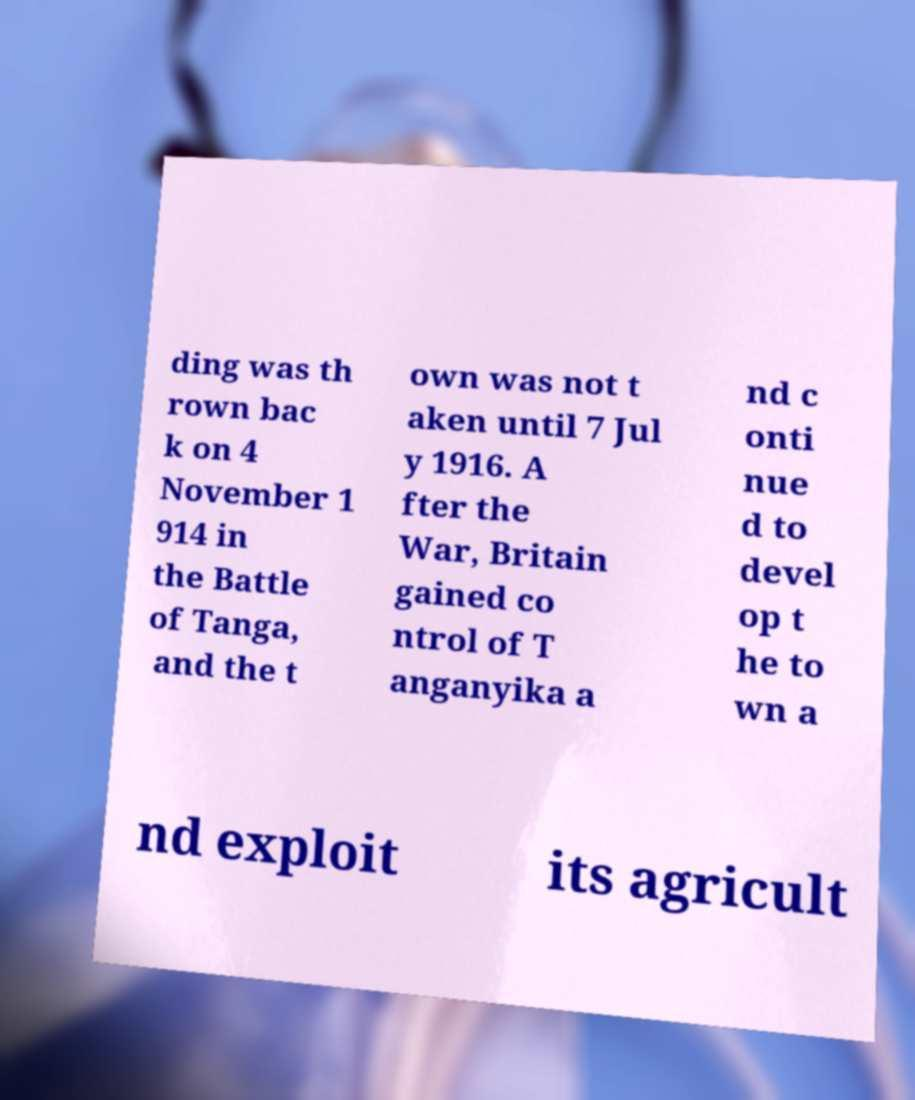Could you extract and type out the text from this image? ding was th rown bac k on 4 November 1 914 in the Battle of Tanga, and the t own was not t aken until 7 Jul y 1916. A fter the War, Britain gained co ntrol of T anganyika a nd c onti nue d to devel op t he to wn a nd exploit its agricult 